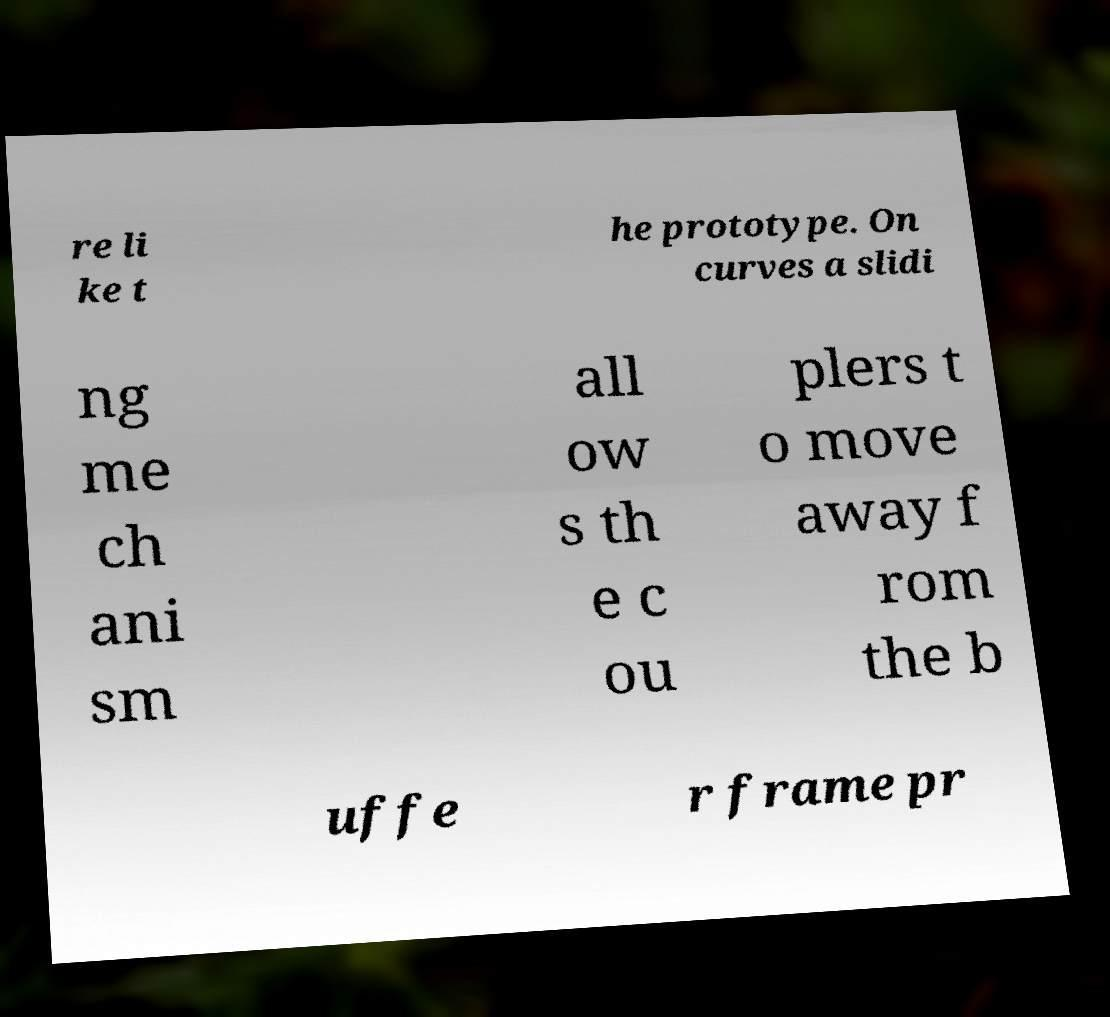Could you assist in decoding the text presented in this image and type it out clearly? re li ke t he prototype. On curves a slidi ng me ch ani sm all ow s th e c ou plers t o move away f rom the b uffe r frame pr 